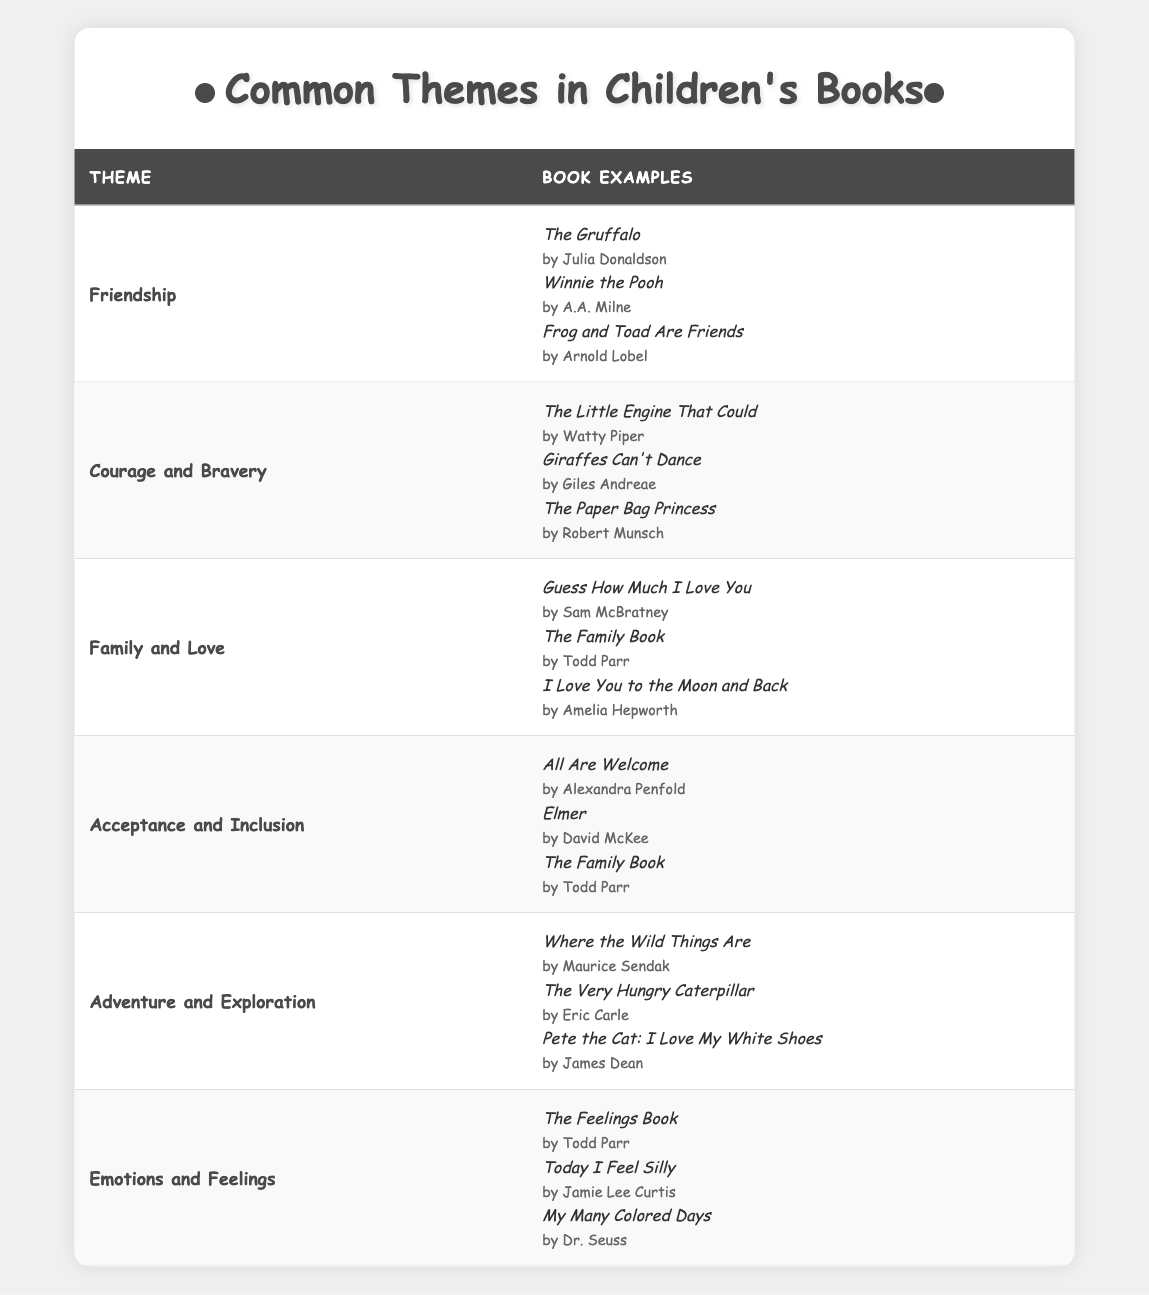What is the theme related to the book "Winnie the Pooh"? According to the table, "Winnie the Pooh" falls under the theme of "Friendship."
Answer: Friendship How many themes are listed in the table? The table displays a total of six themes concerning children's books, namely: Friendship, Courage and Bravery, Family and Love, Acceptance and Inclusion, Adventure and Exploration, and Emotions and Feelings.
Answer: 6 Can you name one book that explores the theme of "Courage and Bravery"? The table provides three examples of books related to "Courage and Bravery," one of which is "The Little Engine That Could" by Watty Piper.
Answer: The Little Engine That Could Is "The Family Book" listed under more than one theme? Yes, "The Family Book" appears under both the "Family and Love" and "Acceptance and Inclusion" themes in the table.
Answer: Yes Which theme has the most examples of books listed? By reviewing the table, the themes "Friendship," "Courage and Bravery," and "Adventure and Exploration" each have three book examples, which is the highest number among all themes.
Answer: Three themes Do all themes have the same number of book examples? No, some themes like "Friendship," "Acceptance and Inclusion," and "Adventure and Exploration" have three book examples, while others may not differ.
Answer: No What are the book titles listed under the theme of "Emotions and Feelings"? The table shows three books listed under "Emotions and Feelings": "The Feelings Book" by Todd Parr, "Today I Feel Silly" by Jamie Lee Curtis, and "My Many Colored Days" by Dr. Seuss.
Answer: The Feelings Book, Today I Feel Silly, My Many Colored Days Which author wrote a book included in both the "Family and Love" and "Acceptance and Inclusion" themes? Upon checking the table, Todd Parr is the author of "The Family Book," which is included in both themes.
Answer: Todd Parr List out the themes that include books focused on adventure. The theme "Adventure and Exploration" includes books like "Where the Wild Things Are," "The Very Hungry Caterpillar," and "Pete the Cat: I Love My White Shoes," which all focus on adventure.
Answer: Adventure and Exploration If you combine the examples from "Acceptance and Inclusion" and "Emotions and Feelings," how many different books do you have in total? The theme "Acceptance and Inclusion" has three books and "Emotions and Feelings" has three books as well, resulting in a total of six book examples when combined.
Answer: 6 